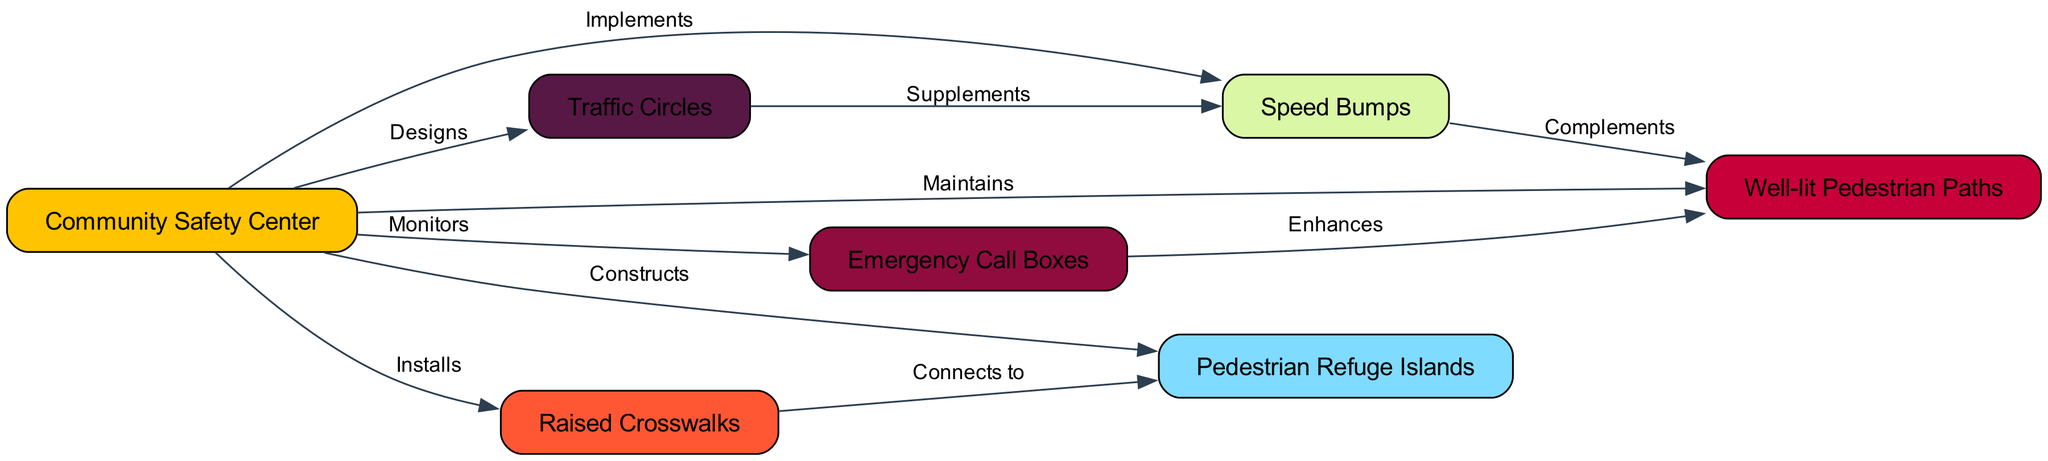What is the total number of nodes in the diagram? The diagram lists several nodes, which are represented in the data under the 'nodes' section. Counting them gives us the values: Community Safety Center, Speed Bumps, Raised Crosswalks, Well-lit Pedestrian Paths, Emergency Call Boxes, Traffic Circles, and Pedestrian Refuge Islands. That's a total of 7.
Answer: 7 Which node does the Community Safety Center monitor? In the diagram, the relationship between the Community Safety Center and the node it monitors is indicated by an edge labeled "Monitors." The only node connected to the Community Safety Center with this label is the Well-lit Pedestrian Paths.
Answer: Well-lit Pedestrian Paths How many edges are connected to the Speed Bumps? By examining the 'edges' data, we find the connections involving Speed Bumps, which only has one outgoing edge leading to Well-lit Pedestrian Paths, and one incoming edge from the Traffic Circles. Therefore, it has a total of 2 connections (1 incoming and 1 outgoing).
Answer: 2 What connection does the Raised Crosswalks have with Pedestrian Refuge Islands? Looking at the edges, the Raised Crosswalks is connected to a node, which is the Pedestrian Refuge Islands, through an edge labeled "Connects to." This indicates a direct relationship between the two nodes.
Answer: Connects to Which measure complements the Speed Bumps? The edge data indicates that the Speed Bumps is complemented by the Well-lit Pedestrian Paths, as it is the only node connected to it with the edge labeled "Complements." This means that the presence of one aids the effectiveness of the other.
Answer: Well-lit Pedestrian Paths What role does the Community Safety Center play regarding the Traffic Circles? According to the edges, the Community Safety Center designs the Traffic Circles, as indicated by the edge labeled "Designs." This shows an organizational role in the planning and implementation of traffic circles for safety.
Answer: Designs Which node enhances the Well-lit Pedestrian Paths? The examination of the edges shows that the Emergency Call Boxes enhance the Well-lit Pedestrian Paths, as depicted by the edge labeled "Enhances." This signifies that the call boxes improve or support the safety of those pedestrian paths.
Answer: Enhances 